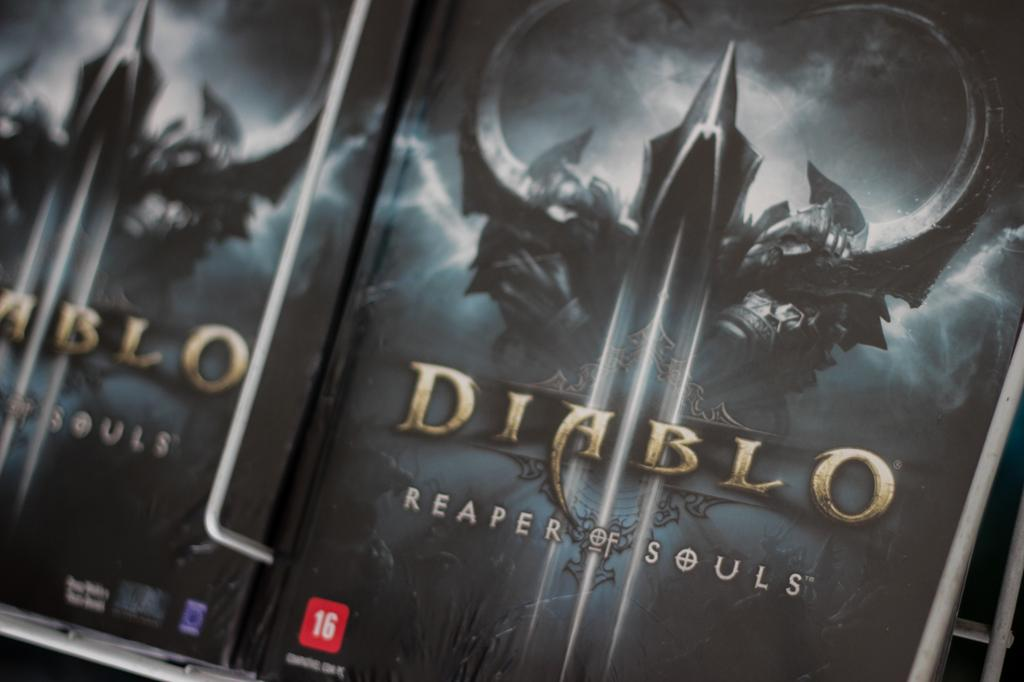<image>
Offer a succinct explanation of the picture presented. Cover for a video game that says DIABLO on the cover. 